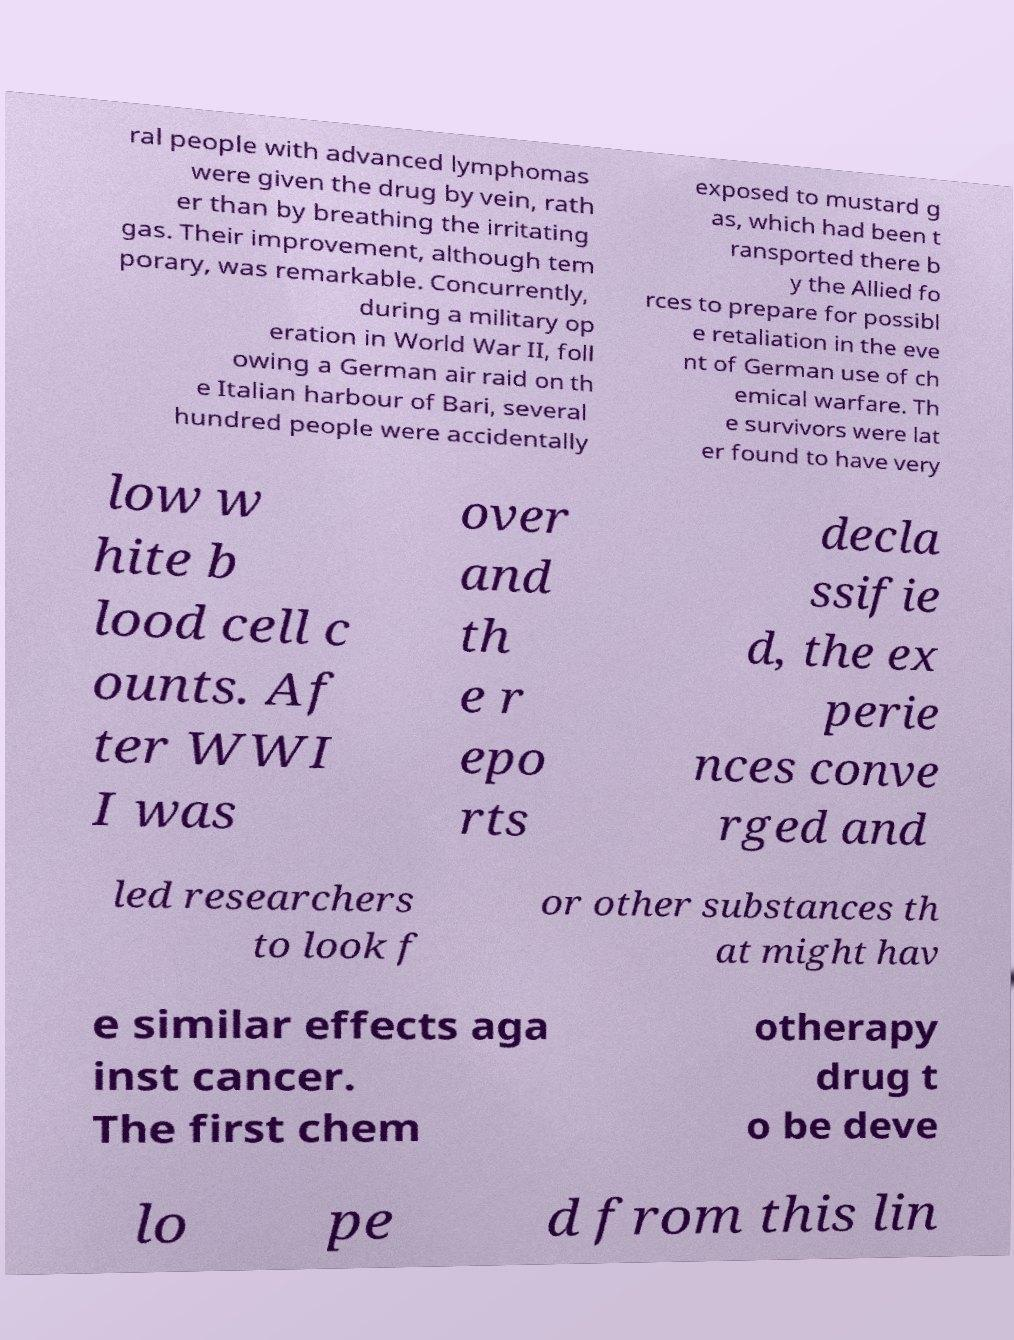For documentation purposes, I need the text within this image transcribed. Could you provide that? ral people with advanced lymphomas were given the drug by vein, rath er than by breathing the irritating gas. Their improvement, although tem porary, was remarkable. Concurrently, during a military op eration in World War II, foll owing a German air raid on th e Italian harbour of Bari, several hundred people were accidentally exposed to mustard g as, which had been t ransported there b y the Allied fo rces to prepare for possibl e retaliation in the eve nt of German use of ch emical warfare. Th e survivors were lat er found to have very low w hite b lood cell c ounts. Af ter WWI I was over and th e r epo rts decla ssifie d, the ex perie nces conve rged and led researchers to look f or other substances th at might hav e similar effects aga inst cancer. The first chem otherapy drug t o be deve lo pe d from this lin 